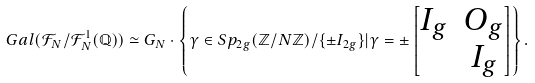<formula> <loc_0><loc_0><loc_500><loc_500>G a l ( \mathcal { F } _ { N } / \mathcal { F } ^ { 1 } _ { N } ( \mathbb { Q } ) ) \simeq G _ { N } \cdot \left \{ \gamma \in S p _ { 2 g } ( \mathbb { Z } / N \mathbb { Z } ) / \{ \pm I _ { 2 g } \} | \gamma = \pm \left [ \begin{matrix} I _ { g } & O _ { g } \\ & I _ { g } \end{matrix} \right ] \right \} .</formula> 